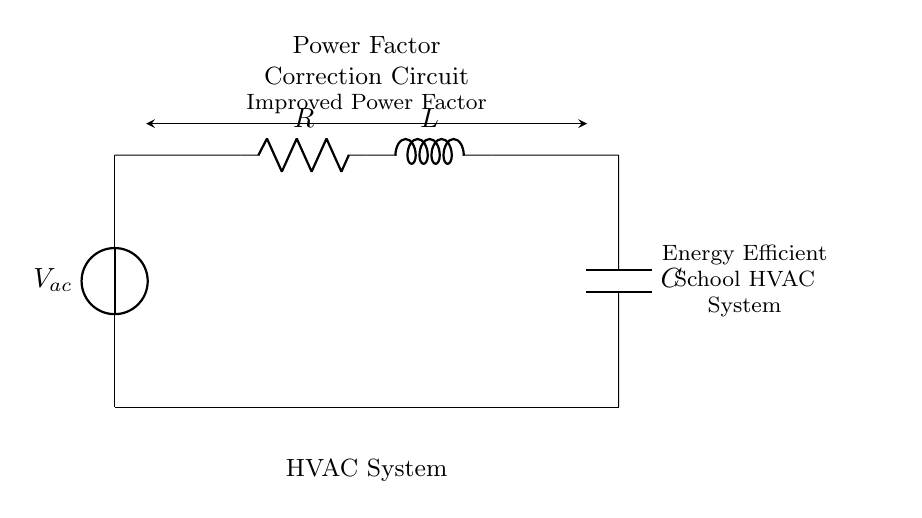What is the type of voltage source in this circuit? The circuit features an alternating voltage source, denoted as V_ac, since it implies that the voltage varies sinusoidally over time, which is common in HVAC systems.
Answer: V_ac What component is used for power factor correction? The component that contributes to power factor correction in an RLC circuit is typically the inductor or capacitor, which compensates for the reactive power caused by inductive loads. In this circuit, both L and C are present, but they work together for correction.
Answer: L and C How many total components are there in the circuit? The circuit contains four main components: one voltage source (V_ac), one resistor (R), one inductor (L), and one capacitor (C). By counting each of these, we arrive at the total.
Answer: Four What is the role of the resistor in this circuit? The resistor in the circuit primarily serves to limit the flow of current and dissipate energy in the form of heat, which is crucial for stability in an HVAC system to prevent circuit issues.
Answer: Current limiting What happens to the power factor when the capacitor is added? Adding the capacitor reduces the total reactive power in the circuit, which effectively improves the power factor by aligning the current and voltage phase angles, leading to increased energy efficiency in the HVAC system.
Answer: Improves What indicates that this is a power factor correction circuit? The labeling of the circuit as a "Power Factor Correction Circuit" and the inclusion of RLC components collectively imply that their arrangement is specifically intended to correct the lagging power factor associated with inductive loads, typical in HVAC applications.
Answer: Power factor correction 